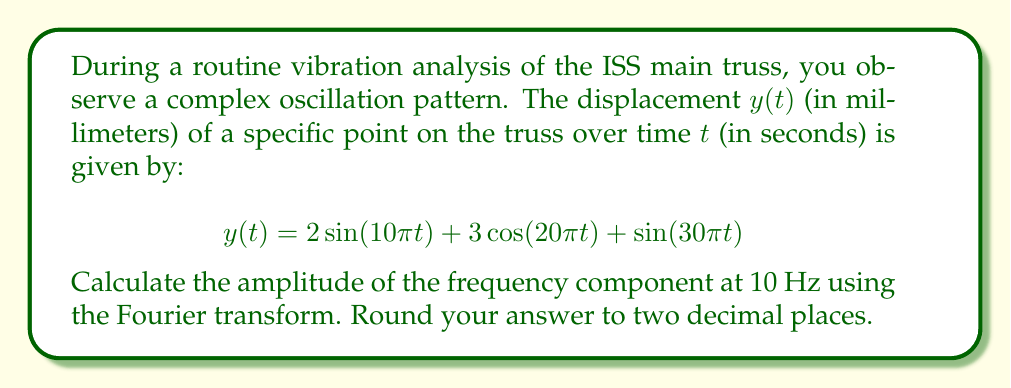Can you solve this math problem? To solve this problem, we'll follow these steps:

1) First, recall that the Fourier transform $F(\omega)$ of a function $f(t)$ is given by:

   $$F(\omega) = \int_{-\infty}^{\infty} f(t) e^{-i\omega t} dt$$

2) In our case, we have three components:
   
   $$y(t) = 2\sin(10\pi t) + 3\cos(20\pi t) + \sin(30\pi t)$$

3) We're interested in the 10 Hz component. Note that $\omega = 2\pi f$, so 10 Hz corresponds to $\omega = 20\pi$ rad/s.

4) For a sinusoidal function $a\sin(\omega_0 t)$, its Fourier transform is:

   $$F(\omega) = \frac{ai}{2}[\delta(\omega - \omega_0) - \delta(\omega + \omega_0)]$$

   where $\delta$ is the Dirac delta function.

5) For a cosinusoidal function $a\cos(\omega_0 t)$, its Fourier transform is:

   $$F(\omega) = \frac{a}{2}[\delta(\omega - \omega_0) + \delta(\omega + \omega_0)]$$

6) In our function, the 10 Hz component is $2\sin(10\pi t)$. This corresponds to $a = 2$ and $\omega_0 = 20\pi$.

7) The amplitude of this component in the frequency domain is given by the magnitude of its Fourier transform at $\omega = 20\pi$:

   $$|F(20\pi)| = \left|\frac{2i}{2}\right| = 1$$

8) However, to get the true amplitude, we need to multiply this by 2 (because the Fourier transform splits the amplitude between positive and negative frequencies).

Therefore, the amplitude of the 10 Hz component is $2 * 1 = 2$ mm.
Answer: 2.00 mm 